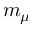<formula> <loc_0><loc_0><loc_500><loc_500>m _ { \mu }</formula> 